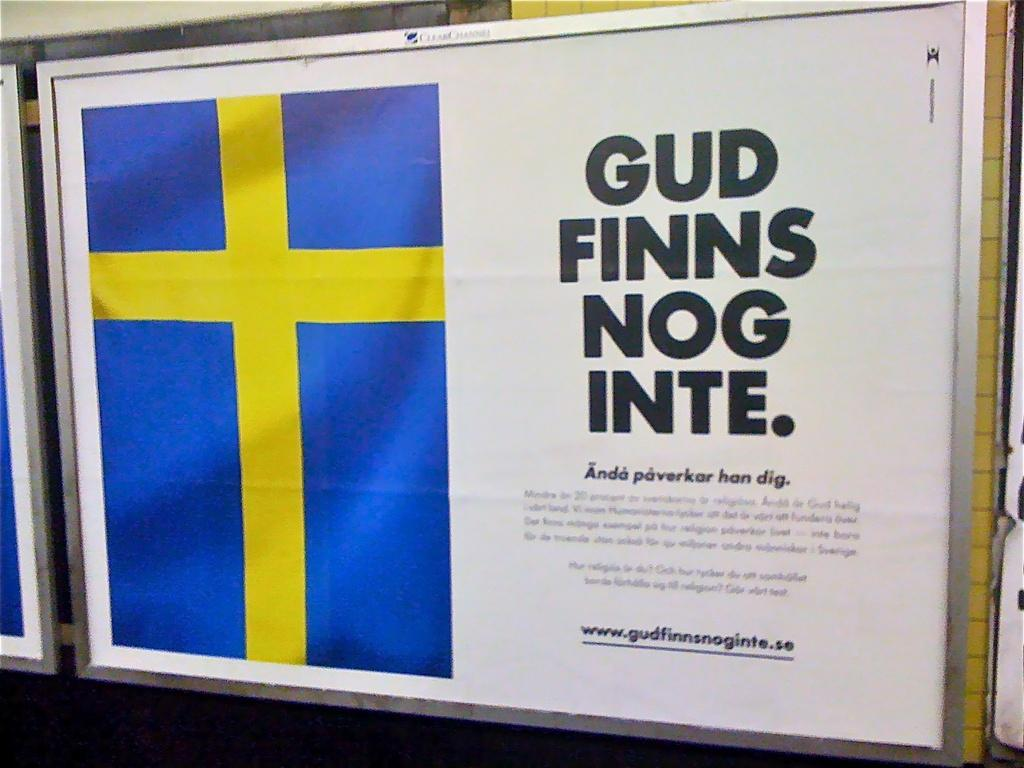Provide a one-sentence caption for the provided image. Paper that says Gud Finns Nog inte and a flag on the left. 